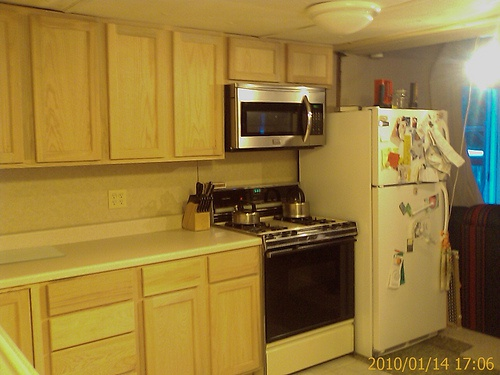Describe the objects in this image and their specific colors. I can see refrigerator in olive and tan tones, oven in olive, black, and maroon tones, microwave in olive, black, maroon, and tan tones, couch in olive, black, maroon, and teal tones, and knife in olive, black, and maroon tones in this image. 